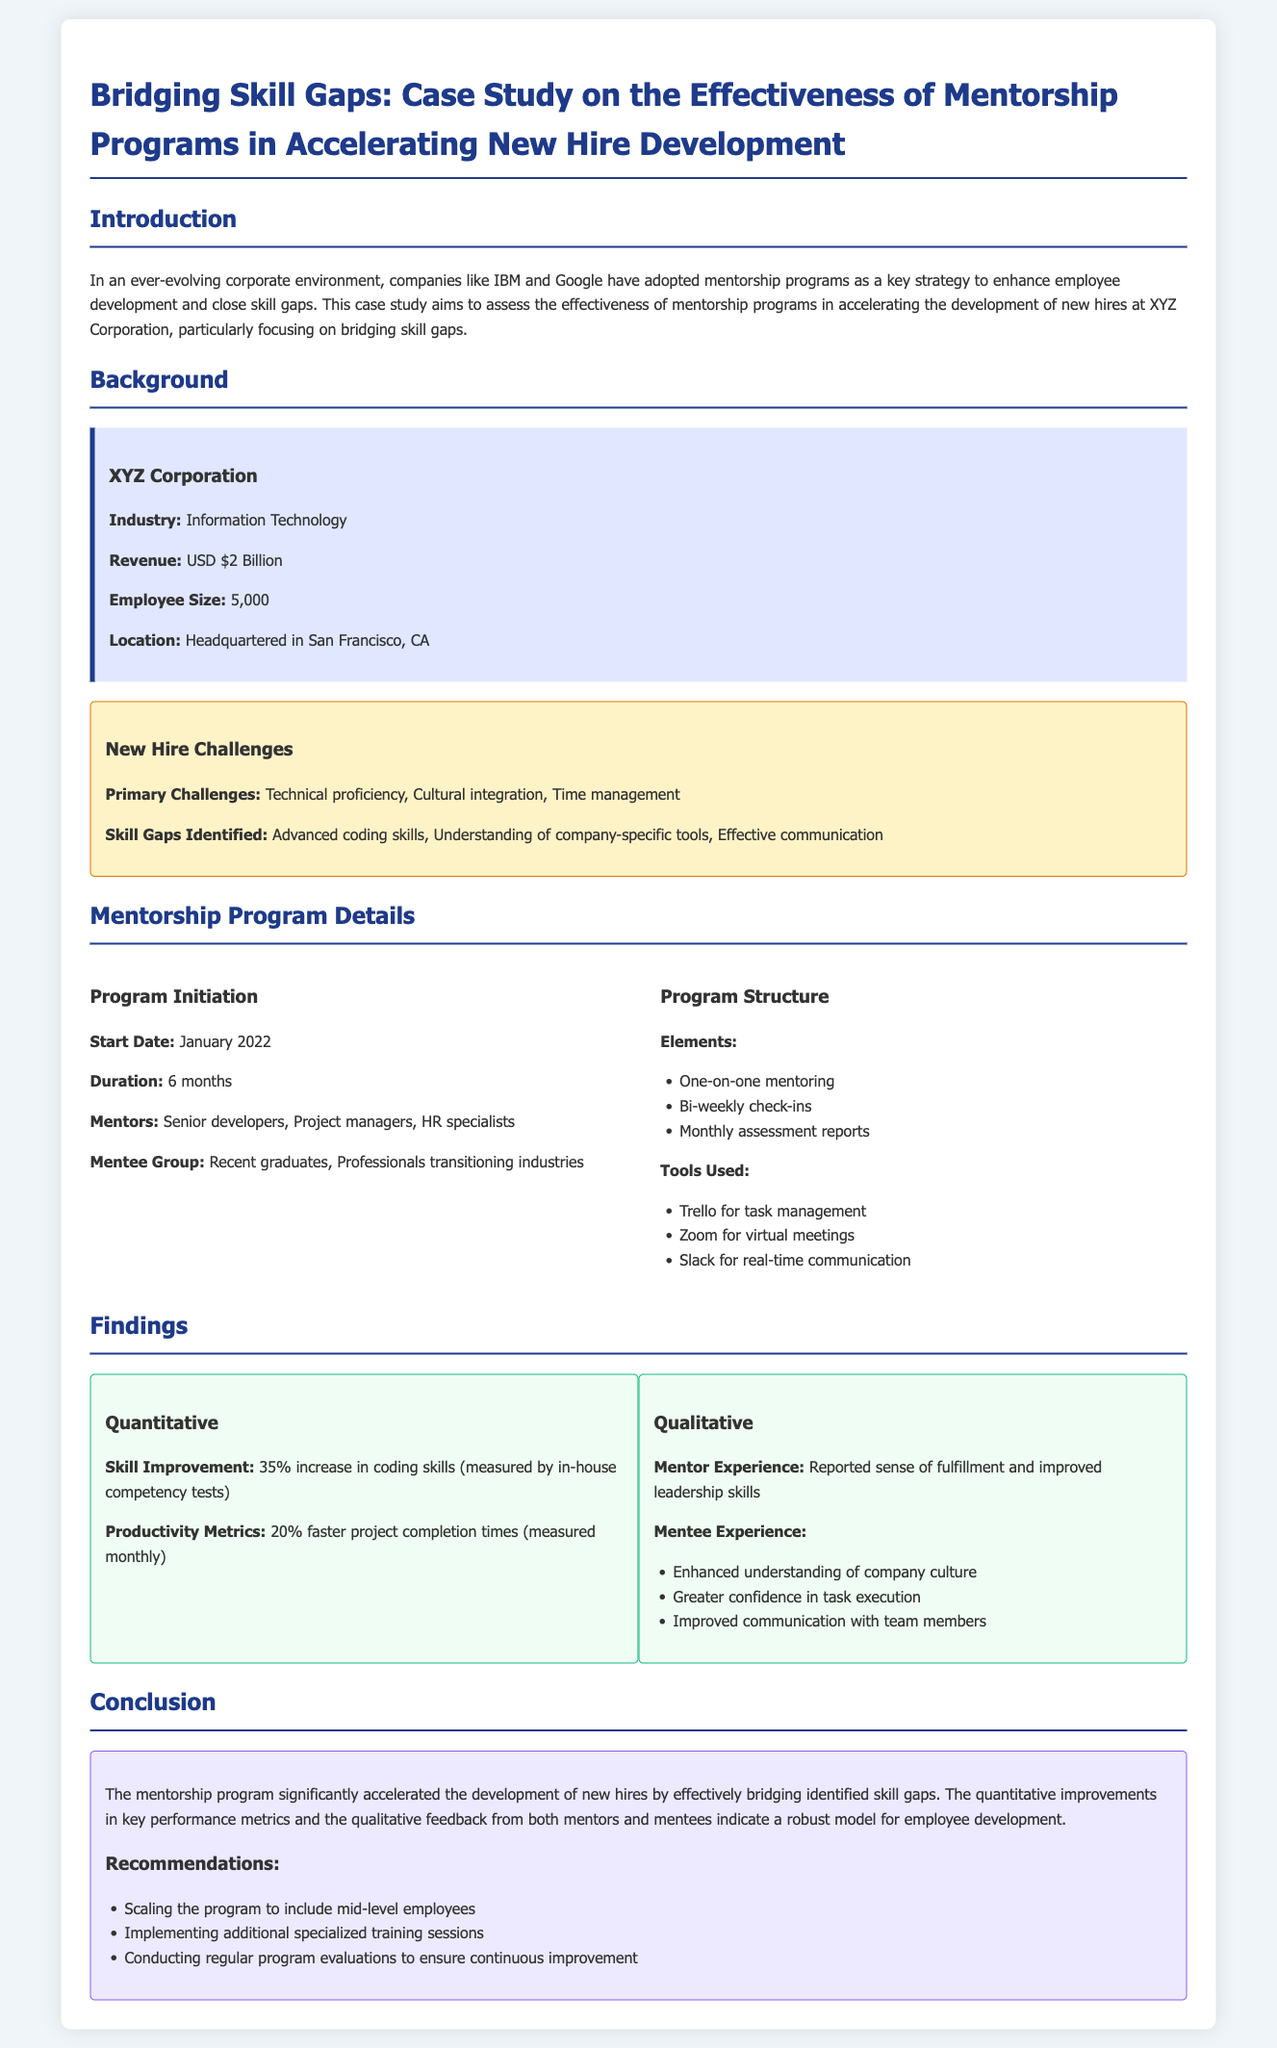What is the industry of XYZ Corporation? The industry of XYZ Corporation is stated in the company profile section of the document.
Answer: Information Technology What was the primary challenge related to new hires? The primary challenges are listed in the challenge box section of the document.
Answer: Technical proficiency What is the duration of the mentorship program? The duration of the mentorship program is mentioned in the program initiation section.
Answer: 6 months What percentage improvement in coding skills was reported? The percentage improvement in coding skills is found in the findings section under quantitative findings.
Answer: 35% Which tool was used for task management? The tool used for task management is listed in the program structure section of the document.
Answer: Trello What type of professionals were included in the mentee group? The types of professionals in the mentee group are specified in the program initiation section.
Answer: Recent graduates What is one qualitative feedback reported by mentees? One piece of qualitative feedback from mentees is found in the findings section under qualitative findings.
Answer: Enhanced understanding of company culture What did the mentorship program aim to bridge? The aim of the mentorship program is articulated in the introduction section of the document.
Answer: Skill gaps What is one recommendation made at the conclusion? Recommendations are listed in the conclusion section of the document.
Answer: Scaling the program to include mid-level employees 